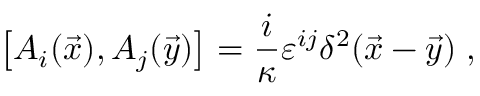Convert formula to latex. <formula><loc_0><loc_0><loc_500><loc_500>\left [ A _ { i } ( \vec { x } ) , A _ { j } ( \vec { y } ) \right ] = \frac { i } { \kappa } \varepsilon ^ { i j } \delta ^ { 2 } ( \vec { x } - \vec { y } ) \, ,</formula> 